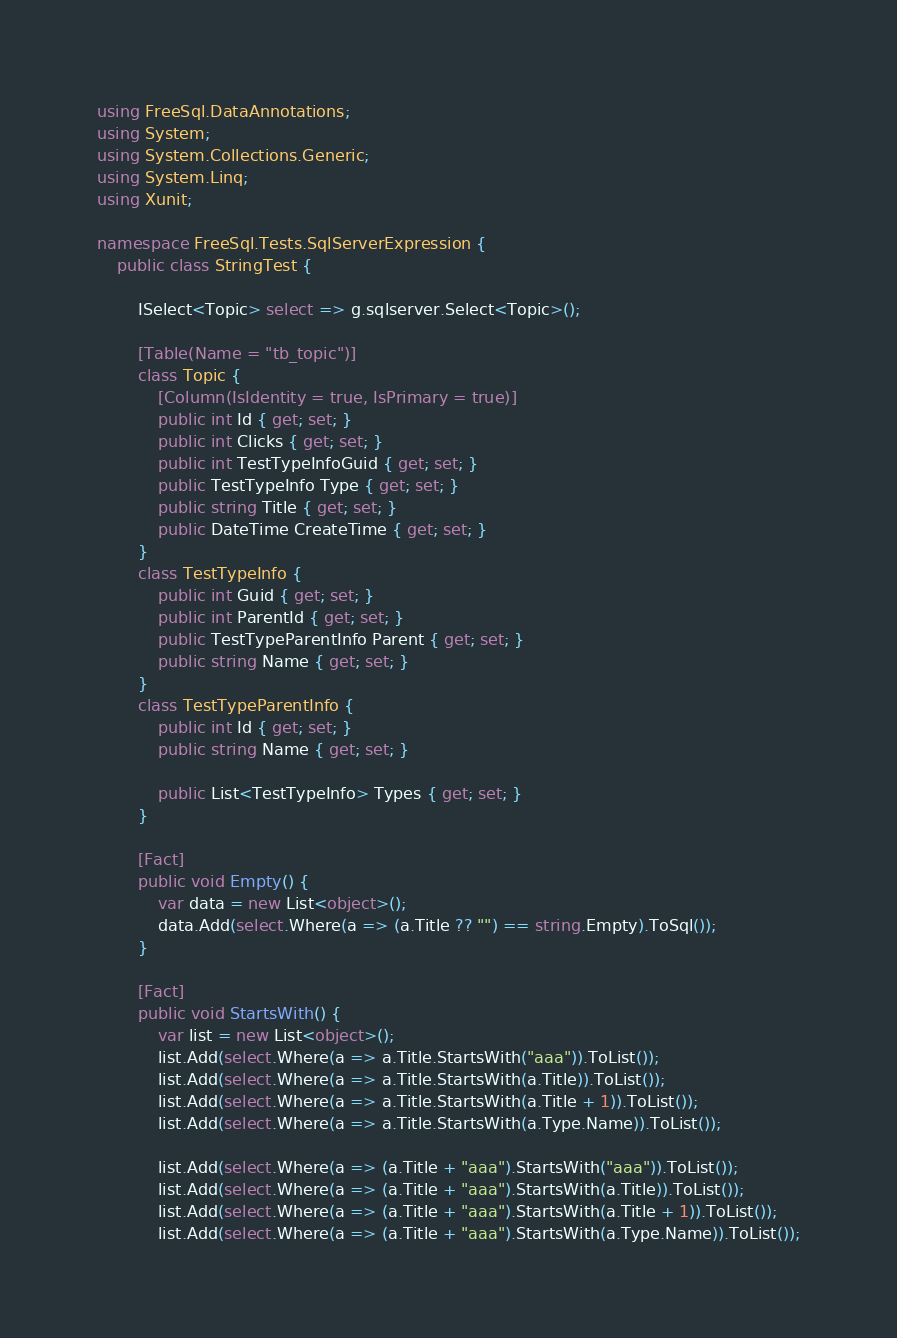<code> <loc_0><loc_0><loc_500><loc_500><_C#_>using FreeSql.DataAnnotations;
using System;
using System.Collections.Generic;
using System.Linq;
using Xunit;

namespace FreeSql.Tests.SqlServerExpression {
	public class StringTest {

		ISelect<Topic> select => g.sqlserver.Select<Topic>();

		[Table(Name = "tb_topic")]
		class Topic {
			[Column(IsIdentity = true, IsPrimary = true)]
			public int Id { get; set; }
			public int Clicks { get; set; }
			public int TestTypeInfoGuid { get; set; }
			public TestTypeInfo Type { get; set; }
			public string Title { get; set; }
			public DateTime CreateTime { get; set; }
		}
		class TestTypeInfo {
			public int Guid { get; set; }
			public int ParentId { get; set; }
			public TestTypeParentInfo Parent { get; set; }
			public string Name { get; set; }
		}
		class TestTypeParentInfo {
			public int Id { get; set; }
			public string Name { get; set; }

			public List<TestTypeInfo> Types { get; set; }
		}

		[Fact]
		public void Empty() {
			var data = new List<object>();
			data.Add(select.Where(a => (a.Title ?? "") == string.Empty).ToSql());
		}

		[Fact]
		public void StartsWith() {
			var list = new List<object>();
			list.Add(select.Where(a => a.Title.StartsWith("aaa")).ToList());
			list.Add(select.Where(a => a.Title.StartsWith(a.Title)).ToList());
			list.Add(select.Where(a => a.Title.StartsWith(a.Title + 1)).ToList());
			list.Add(select.Where(a => a.Title.StartsWith(a.Type.Name)).ToList());

			list.Add(select.Where(a => (a.Title + "aaa").StartsWith("aaa")).ToList());
			list.Add(select.Where(a => (a.Title + "aaa").StartsWith(a.Title)).ToList());
			list.Add(select.Where(a => (a.Title + "aaa").StartsWith(a.Title + 1)).ToList());
			list.Add(select.Where(a => (a.Title + "aaa").StartsWith(a.Type.Name)).ToList());</code> 